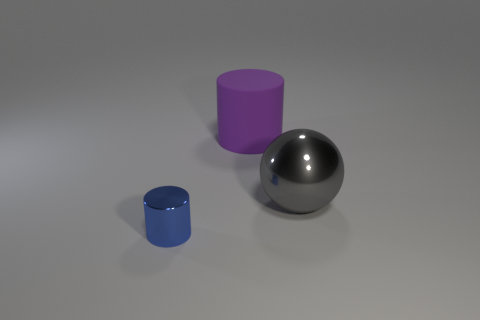Add 1 big balls. How many objects exist? 4 Subtract all blue cylinders. How many cylinders are left? 1 Subtract all spheres. How many objects are left? 2 Add 1 tiny objects. How many tiny objects are left? 2 Add 3 big rubber cylinders. How many big rubber cylinders exist? 4 Subtract 0 red cylinders. How many objects are left? 3 Subtract 1 spheres. How many spheres are left? 0 Subtract all green balls. Subtract all green cylinders. How many balls are left? 1 Subtract all large purple metal spheres. Subtract all metal cylinders. How many objects are left? 2 